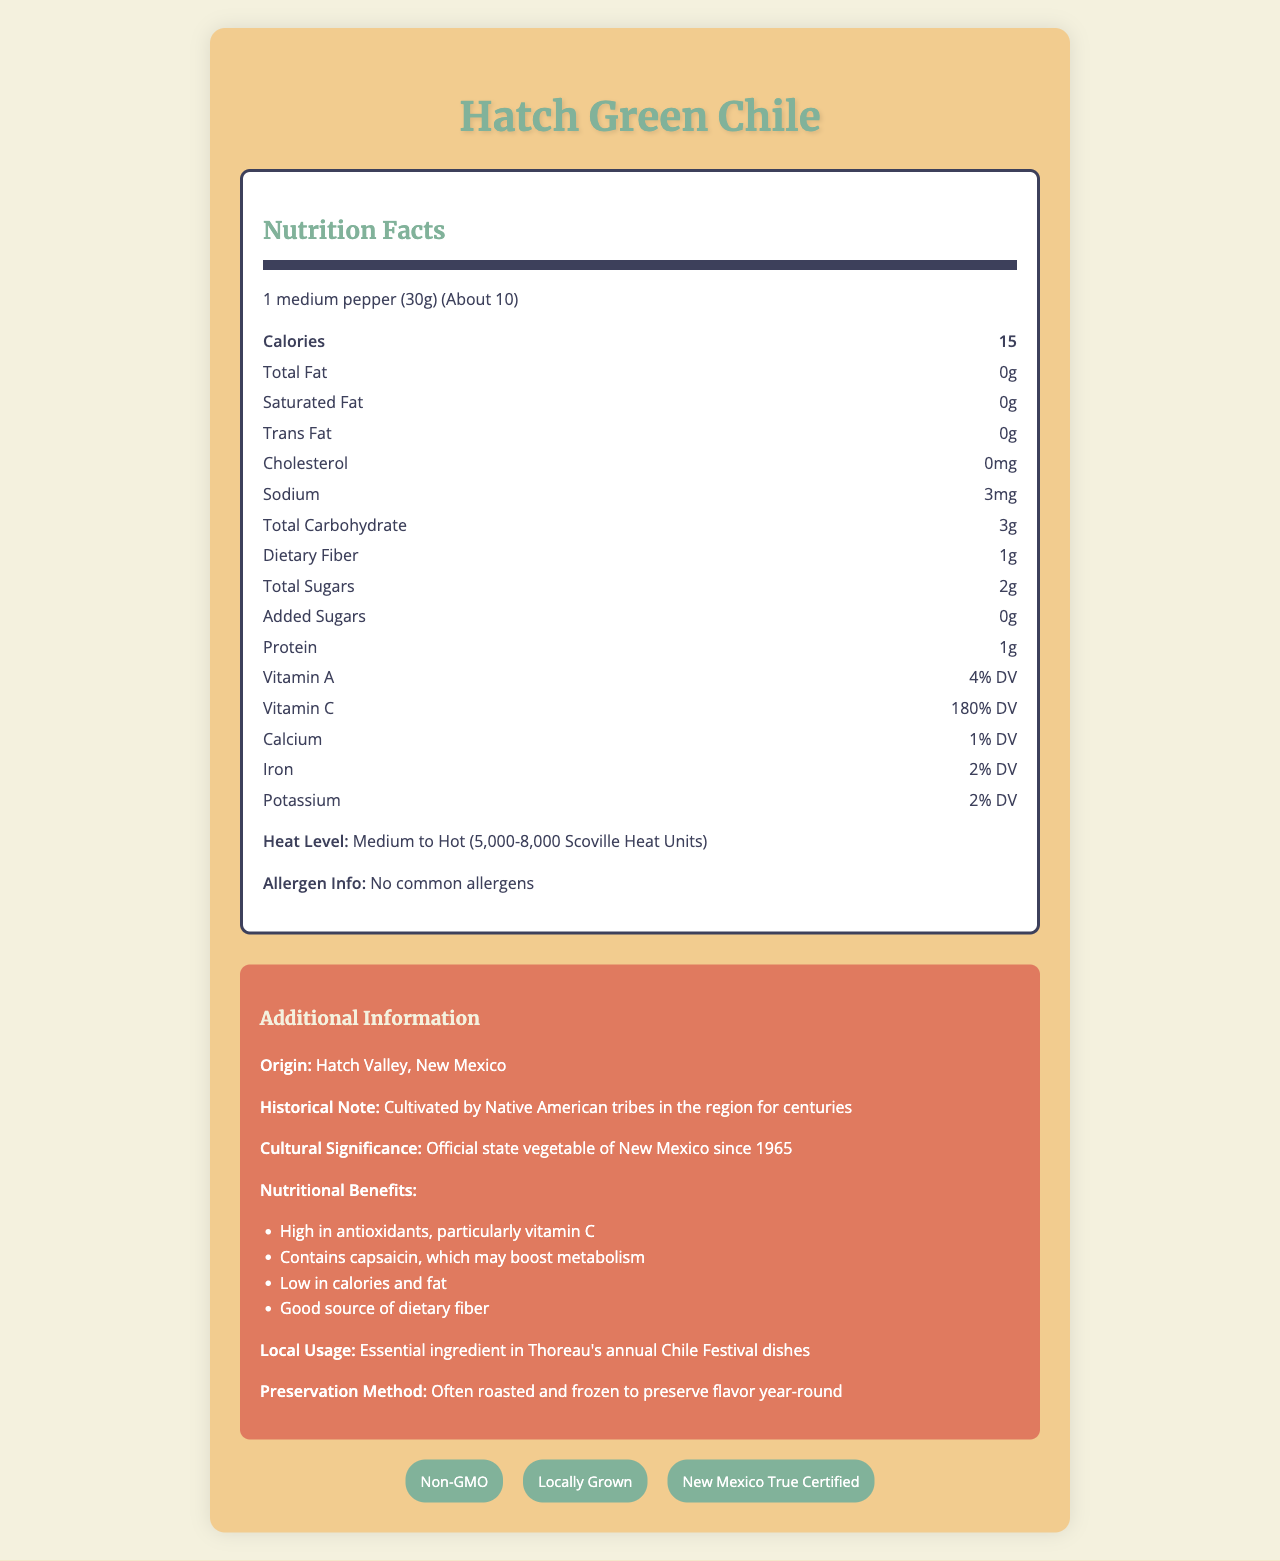who is the document about? The title of the document reads "Nutrition Facts: Hatch Green Chile," indicating that the document is about this specific product.
Answer: Hatch Green Chile what is the serving size? The serving size information is specified in the nutrition label section of the document.
Answer: 1 medium pepper (30g) how many calories are there per serving? The document lists the calories per serving in the nutrition label as 15.
Answer: 15 calories what is the heat level of the Hatch Green Chile? The heat level information is clearly mentioned towards the bottom of the nutrition label section.
Answer: Medium to Hot (5,000-8,000 Scoville Heat Units) how much vitamin C is provided in one serving? The document states that one serving contains 180% of the daily value for vitamin C.
Answer: 180% DV what is the origin of Hatch Green Chile? The additional information section specifies that Hatch Green Chile originates from Hatch Valley, New Mexico.
Answer: Hatch Valley, New Mexico which type of fat is present in Hatch Green Chile? A. Total Fat B. Saturated Fat C. Trans Fat D. None The nutrition label shows that all types of fat (Total Fat, Saturated Fat, Trans Fat) are 0g.
Answer: D. None what is the cholesterol content per serving of Hatch Green Chile? A. 0mg B. 3mg C. 15mg D. 30mg According to the nutrition label, the cholesterol content per serving is 0mg.
Answer: A. 0mg is Hatch Green Chile a significant source of dietary fiber? It provides 1g of dietary fiber per serving, contributing to the daily fiber intake.
Answer: Yes can Hatch Green Chile be preserved throughout the year? The additional information states that they are often roasted and frozen to preserve flavor year-round.
Answer: Yes does Hatch Green Chile contain any common allergens? Under allergen information, it is mentioned that there are no common allergens.
Answer: No describe the main idea of the document. The document includes comprehensive data on the serving size, calories, nutrients, heat level in Scoville Heat Units, allergen information, and certifications along with details on its historical and cultural significance.
Answer: The document provides a detailed nutritional profile and additional information about Hatch Green Chile, a local variety from Hatch Valley, New Mexico. It highlights its nutritional benefits, cultural significance, and certifications. what are some certifications of the Hatch Green Chile? The certifications are listed at the bottom of the document with their respective badges.
Answer: Non-GMO, Locally Grown, New Mexico True Certified what is the official state vegetable of New Mexico? The document mentions in the additional information that the Hatch Green Chile has been the official state vegetable of New Mexico since 1965.
Answer: Hatch Green Chile how does capsaicin in Hatch Green Chile benefit health? One of the nutritional benefits listed in the additional information section is that capsaicin may help to boost metabolism.
Answer: It may boost metabolism is the Hatch Green Chile a high-calorie food? With only 15 calories per serving, Hatch Green Chile is considered low in calories.
Answer: No what is the local usage of Hatch Green Chile in Thoreau? The additional information states that it is an essential ingredient in Thoreau's annual Chile Festival dishes.
Answer: Essential ingredient in Thoreau's annual Chile Festival dishes how much iron is provided in one serving? The iron content per serving is listed in the nutrition label as 2% of the daily value.
Answer: 2% DV is the fiber content of Hatch Green Chile high or low? With 1g of dietary fiber per serving, the fiber content is relatively low.
Answer: Low what varieties of certifications does Hatch Green Chile have? The document does not provide an exhaustive list of all possible certification varieties; it only lists specific certifications it has received.
Answer: Not enough information 